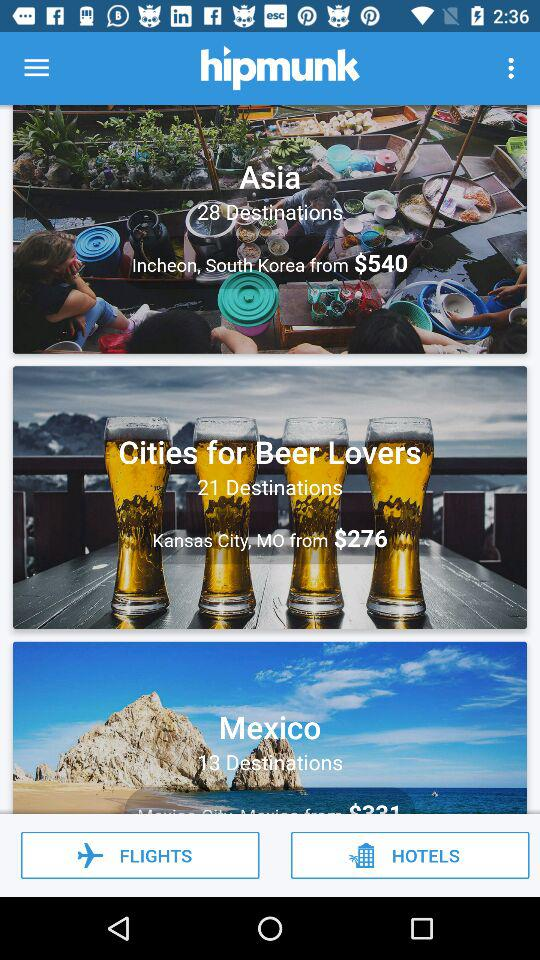How many destinations are there in Mexico? There are 13 destinations in Mexico. 